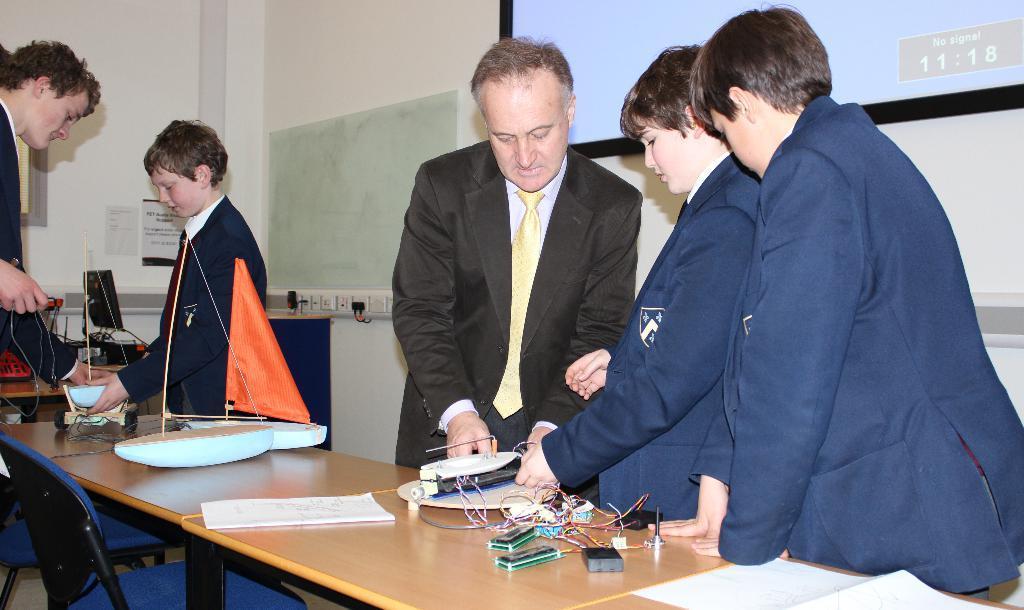How would you summarize this image in a sentence or two? In this picture there are five people standing around the table on which there are some things and papers and behind them there is a projector screen. 